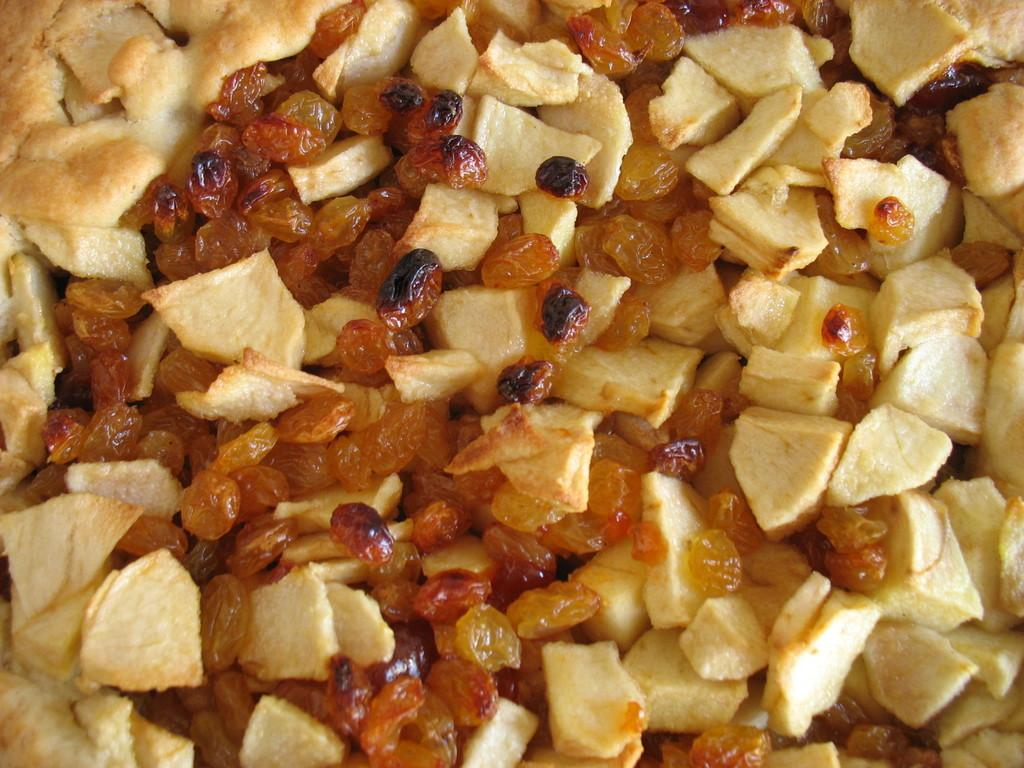What can be seen in the image in terms of food? There are different types of food in the image. Can you describe the colors of the food? The colors of the food are brown and yellow. How many toys are visible in the image? There are no toys present in the image; it only features different types of food. 